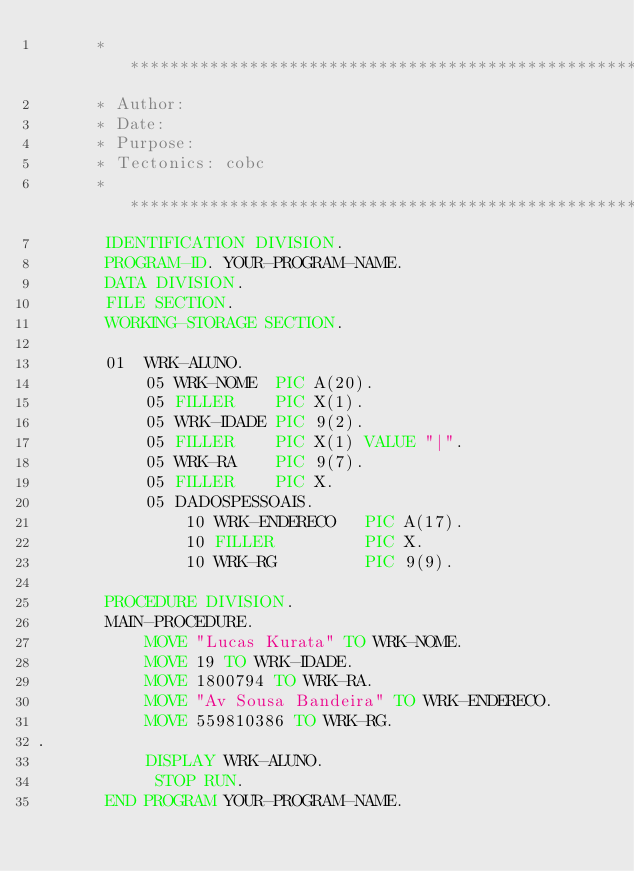<code> <loc_0><loc_0><loc_500><loc_500><_COBOL_>      ******************************************************************
      * Author:
      * Date:
      * Purpose:
      * Tectonics: cobc
      ******************************************************************
       IDENTIFICATION DIVISION.
       PROGRAM-ID. YOUR-PROGRAM-NAME.
       DATA DIVISION.
       FILE SECTION.
       WORKING-STORAGE SECTION.

       01  WRK-ALUNO.
           05 WRK-NOME  PIC A(20).
           05 FILLER    PIC X(1).
           05 WRK-IDADE PIC 9(2).
           05 FILLER    PIC X(1) VALUE "|".
           05 WRK-RA    PIC 9(7).
           05 FILLER    PIC X.
           05 DADOSPESSOAIS.
               10 WRK-ENDERECO   PIC A(17).
               10 FILLER         PIC X.
               10 WRK-RG         PIC 9(9).

       PROCEDURE DIVISION.
       MAIN-PROCEDURE.
           MOVE "Lucas Kurata" TO WRK-NOME.
           MOVE 19 TO WRK-IDADE.
           MOVE 1800794 TO WRK-RA.
           MOVE "Av Sousa Bandeira" TO WRK-ENDERECO.
           MOVE 559810386 TO WRK-RG.
.
           DISPLAY WRK-ALUNO.
            STOP RUN.
       END PROGRAM YOUR-PROGRAM-NAME.
</code> 